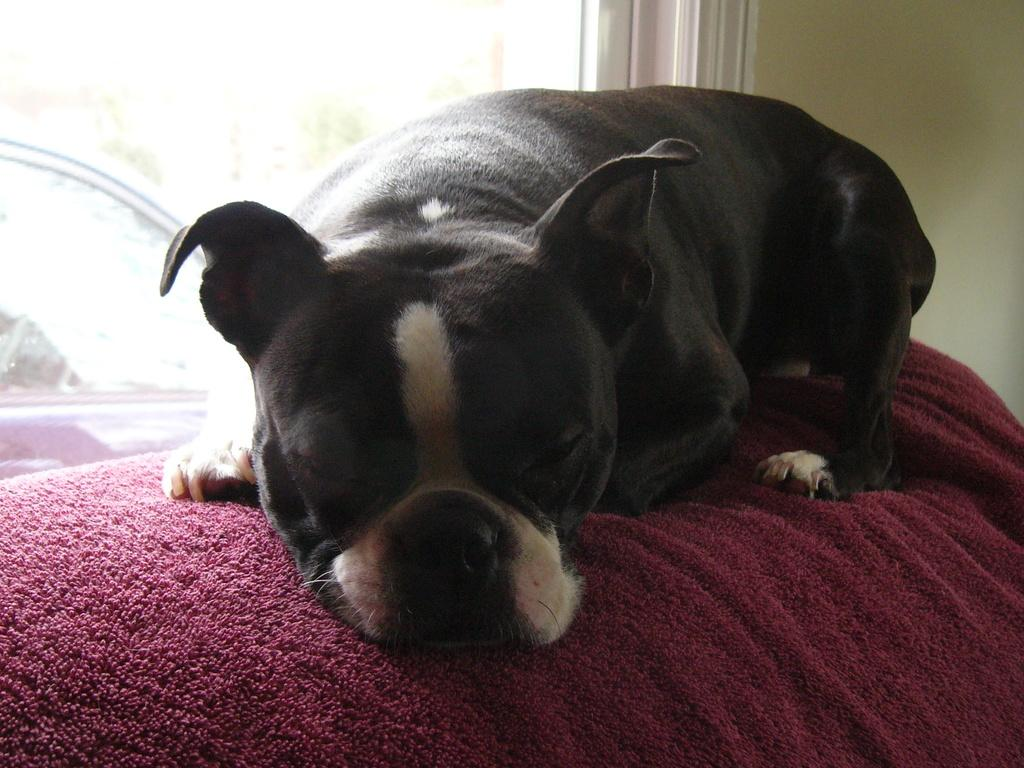What type of animal is in the image? There is a bull dog in the image. What is the bull dog doing? The bull dog is sleeping. What color is the bull dog? The bull dog is black in color. What is the bull dog resting on? The bull dog is on a maroon towel. What can be seen in the background of the image? There are windows and a wall in the image. How many rabbits are playing with the kitty in the image? There are no rabbits or kitty present in the image; it features a sleeping black bull dog on a maroon towel. 